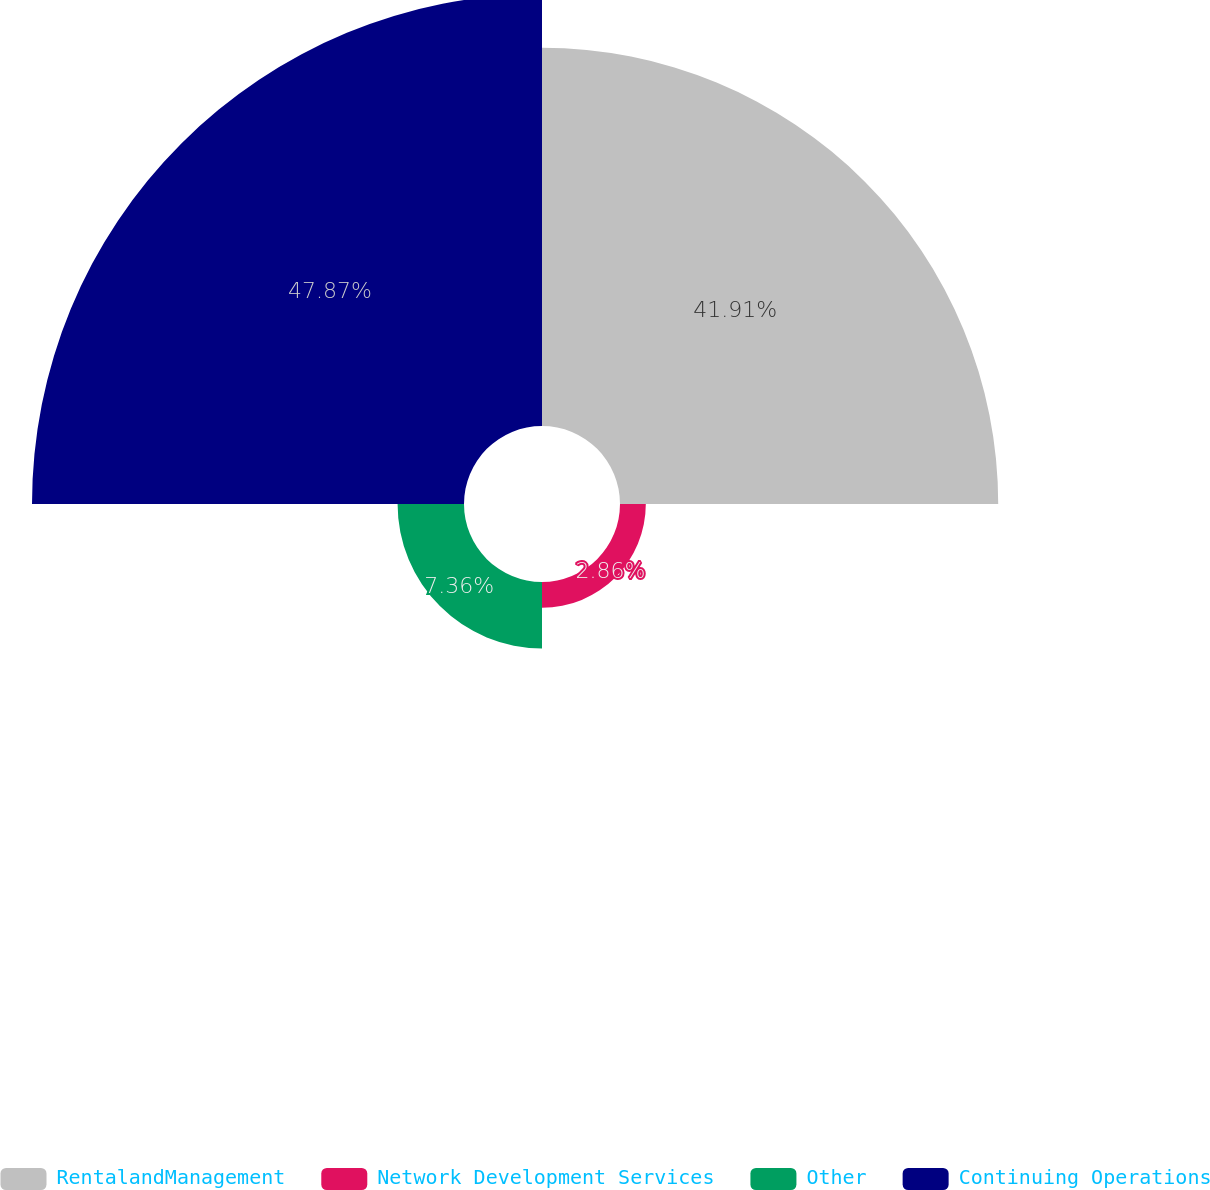Convert chart to OTSL. <chart><loc_0><loc_0><loc_500><loc_500><pie_chart><fcel>RentalandManagement<fcel>Network Development Services<fcel>Other<fcel>Continuing Operations<nl><fcel>41.91%<fcel>2.86%<fcel>7.36%<fcel>47.87%<nl></chart> 